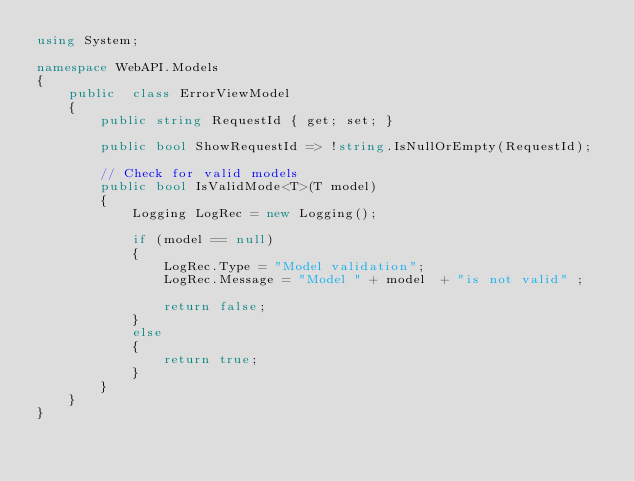<code> <loc_0><loc_0><loc_500><loc_500><_C#_>using System;

namespace WebAPI.Models
{
    public  class ErrorViewModel
    {
        public string RequestId { get; set; }

        public bool ShowRequestId => !string.IsNullOrEmpty(RequestId);

        // Check for valid models 
        public bool IsValidMode<T>(T model)
        {
            Logging LogRec = new Logging();

            if (model == null)
            {
                LogRec.Type = "Model validation";
                LogRec.Message = "Model " + model  + "is not valid" ;

                return false;
            }
            else
            {
                return true;
            }
        }
    }
}</code> 